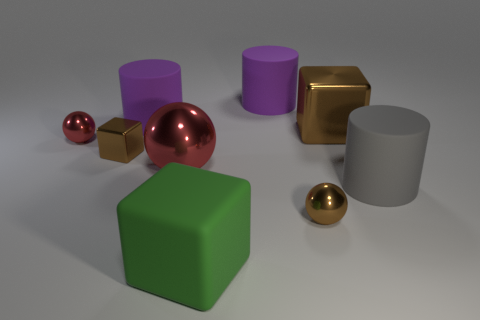Add 1 red balls. How many objects exist? 10 Subtract all large shiny spheres. How many spheres are left? 2 Subtract all red spheres. How many spheres are left? 1 Subtract all green blocks. How many red balls are left? 2 Subtract all cylinders. How many objects are left? 6 Subtract 2 blocks. How many blocks are left? 1 Add 6 rubber cubes. How many rubber cubes are left? 7 Add 1 big metal spheres. How many big metal spheres exist? 2 Subtract 1 red balls. How many objects are left? 8 Subtract all gray cubes. Subtract all yellow balls. How many cubes are left? 3 